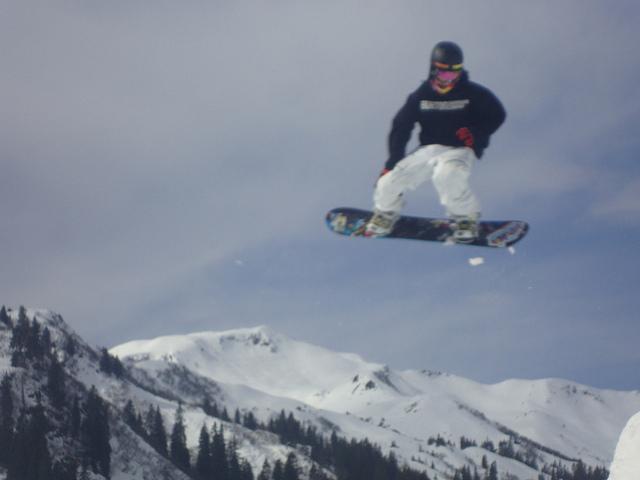Is the board strapped to the person's feet?
Answer briefly. Yes. Who are the top of the hill?
Keep it brief. Snowboarders. What sport is shown?
Write a very short answer. Snowboarding. What kind of trees are on the mountain?
Answer briefly. Pine. Is the snow in this photo natural or man made?
Quick response, please. Natural. 